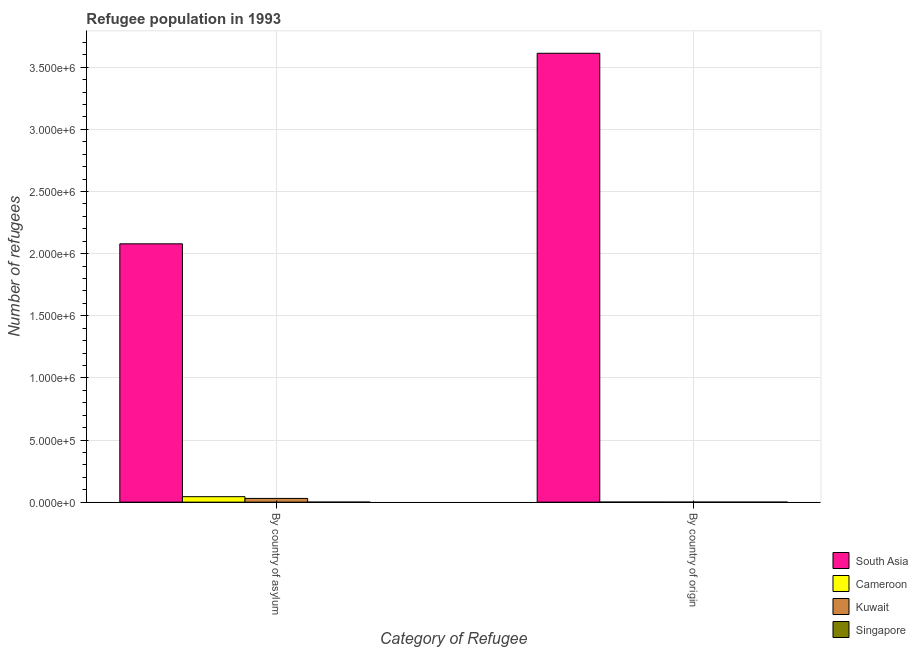How many groups of bars are there?
Offer a very short reply. 2. How many bars are there on the 1st tick from the left?
Ensure brevity in your answer.  4. How many bars are there on the 2nd tick from the right?
Make the answer very short. 4. What is the label of the 1st group of bars from the left?
Keep it short and to the point. By country of asylum. What is the number of refugees by country of asylum in Cameroon?
Provide a succinct answer. 4.40e+04. Across all countries, what is the maximum number of refugees by country of origin?
Offer a very short reply. 3.61e+06. Across all countries, what is the minimum number of refugees by country of asylum?
Ensure brevity in your answer.  11. In which country was the number of refugees by country of asylum minimum?
Your response must be concise. Singapore. What is the total number of refugees by country of asylum in the graph?
Provide a short and direct response. 2.15e+06. What is the difference between the number of refugees by country of origin in Singapore and that in Cameroon?
Provide a succinct answer. -172. What is the difference between the number of refugees by country of asylum in Cameroon and the number of refugees by country of origin in South Asia?
Provide a short and direct response. -3.57e+06. What is the average number of refugees by country of origin per country?
Keep it short and to the point. 9.03e+05. What is the difference between the number of refugees by country of asylum and number of refugees by country of origin in Singapore?
Keep it short and to the point. 10. In how many countries, is the number of refugees by country of origin greater than 700000 ?
Ensure brevity in your answer.  1. What is the ratio of the number of refugees by country of asylum in Cameroon to that in Singapore?
Your answer should be very brief. 4001.18. Is the number of refugees by country of origin in Cameroon less than that in South Asia?
Your answer should be compact. Yes. What does the 4th bar from the left in By country of origin represents?
Your response must be concise. Singapore. What does the 1st bar from the right in By country of origin represents?
Offer a terse response. Singapore. How many bars are there?
Give a very brief answer. 8. Are the values on the major ticks of Y-axis written in scientific E-notation?
Provide a short and direct response. Yes. Does the graph contain any zero values?
Provide a succinct answer. No. How are the legend labels stacked?
Offer a very short reply. Vertical. What is the title of the graph?
Your response must be concise. Refugee population in 1993. What is the label or title of the X-axis?
Provide a short and direct response. Category of Refugee. What is the label or title of the Y-axis?
Make the answer very short. Number of refugees. What is the Number of refugees of South Asia in By country of asylum?
Keep it short and to the point. 2.08e+06. What is the Number of refugees of Cameroon in By country of asylum?
Ensure brevity in your answer.  4.40e+04. What is the Number of refugees in Singapore in By country of asylum?
Provide a short and direct response. 11. What is the Number of refugees in South Asia in By country of origin?
Give a very brief answer. 3.61e+06. What is the Number of refugees of Cameroon in By country of origin?
Offer a very short reply. 173. What is the Number of refugees of Kuwait in By country of origin?
Provide a short and direct response. 89. Across all Category of Refugee, what is the maximum Number of refugees of South Asia?
Provide a succinct answer. 3.61e+06. Across all Category of Refugee, what is the maximum Number of refugees in Cameroon?
Provide a short and direct response. 4.40e+04. Across all Category of Refugee, what is the maximum Number of refugees in Kuwait?
Provide a succinct answer. 3.00e+04. Across all Category of Refugee, what is the maximum Number of refugees in Singapore?
Give a very brief answer. 11. Across all Category of Refugee, what is the minimum Number of refugees in South Asia?
Give a very brief answer. 2.08e+06. Across all Category of Refugee, what is the minimum Number of refugees of Cameroon?
Your answer should be very brief. 173. Across all Category of Refugee, what is the minimum Number of refugees of Kuwait?
Your answer should be very brief. 89. Across all Category of Refugee, what is the minimum Number of refugees of Singapore?
Ensure brevity in your answer.  1. What is the total Number of refugees of South Asia in the graph?
Give a very brief answer. 5.69e+06. What is the total Number of refugees in Cameroon in the graph?
Offer a terse response. 4.42e+04. What is the total Number of refugees in Kuwait in the graph?
Ensure brevity in your answer.  3.01e+04. What is the total Number of refugees of Singapore in the graph?
Provide a short and direct response. 12. What is the difference between the Number of refugees of South Asia in By country of asylum and that in By country of origin?
Your response must be concise. -1.53e+06. What is the difference between the Number of refugees of Cameroon in By country of asylum and that in By country of origin?
Your response must be concise. 4.38e+04. What is the difference between the Number of refugees in Kuwait in By country of asylum and that in By country of origin?
Ensure brevity in your answer.  2.99e+04. What is the difference between the Number of refugees of Singapore in By country of asylum and that in By country of origin?
Ensure brevity in your answer.  10. What is the difference between the Number of refugees in South Asia in By country of asylum and the Number of refugees in Cameroon in By country of origin?
Offer a terse response. 2.08e+06. What is the difference between the Number of refugees in South Asia in By country of asylum and the Number of refugees in Kuwait in By country of origin?
Keep it short and to the point. 2.08e+06. What is the difference between the Number of refugees in South Asia in By country of asylum and the Number of refugees in Singapore in By country of origin?
Provide a short and direct response. 2.08e+06. What is the difference between the Number of refugees of Cameroon in By country of asylum and the Number of refugees of Kuwait in By country of origin?
Provide a short and direct response. 4.39e+04. What is the difference between the Number of refugees in Cameroon in By country of asylum and the Number of refugees in Singapore in By country of origin?
Provide a short and direct response. 4.40e+04. What is the difference between the Number of refugees of Kuwait in By country of asylum and the Number of refugees of Singapore in By country of origin?
Your answer should be compact. 3.00e+04. What is the average Number of refugees in South Asia per Category of Refugee?
Offer a terse response. 2.85e+06. What is the average Number of refugees of Cameroon per Category of Refugee?
Make the answer very short. 2.21e+04. What is the average Number of refugees of Kuwait per Category of Refugee?
Provide a succinct answer. 1.50e+04. What is the difference between the Number of refugees of South Asia and Number of refugees of Cameroon in By country of asylum?
Keep it short and to the point. 2.03e+06. What is the difference between the Number of refugees in South Asia and Number of refugees in Kuwait in By country of asylum?
Offer a very short reply. 2.05e+06. What is the difference between the Number of refugees of South Asia and Number of refugees of Singapore in By country of asylum?
Offer a terse response. 2.08e+06. What is the difference between the Number of refugees in Cameroon and Number of refugees in Kuwait in By country of asylum?
Give a very brief answer. 1.40e+04. What is the difference between the Number of refugees in Cameroon and Number of refugees in Singapore in By country of asylum?
Your answer should be compact. 4.40e+04. What is the difference between the Number of refugees of Kuwait and Number of refugees of Singapore in By country of asylum?
Ensure brevity in your answer.  3.00e+04. What is the difference between the Number of refugees of South Asia and Number of refugees of Cameroon in By country of origin?
Your response must be concise. 3.61e+06. What is the difference between the Number of refugees of South Asia and Number of refugees of Kuwait in By country of origin?
Provide a short and direct response. 3.61e+06. What is the difference between the Number of refugees of South Asia and Number of refugees of Singapore in By country of origin?
Your answer should be very brief. 3.61e+06. What is the difference between the Number of refugees of Cameroon and Number of refugees of Singapore in By country of origin?
Your response must be concise. 172. What is the difference between the Number of refugees of Kuwait and Number of refugees of Singapore in By country of origin?
Make the answer very short. 88. What is the ratio of the Number of refugees in South Asia in By country of asylum to that in By country of origin?
Your response must be concise. 0.58. What is the ratio of the Number of refugees in Cameroon in By country of asylum to that in By country of origin?
Provide a short and direct response. 254.41. What is the ratio of the Number of refugees of Kuwait in By country of asylum to that in By country of origin?
Give a very brief answer. 337.08. What is the ratio of the Number of refugees of Singapore in By country of asylum to that in By country of origin?
Offer a very short reply. 11. What is the difference between the highest and the second highest Number of refugees of South Asia?
Make the answer very short. 1.53e+06. What is the difference between the highest and the second highest Number of refugees of Cameroon?
Keep it short and to the point. 4.38e+04. What is the difference between the highest and the second highest Number of refugees of Kuwait?
Keep it short and to the point. 2.99e+04. What is the difference between the highest and the second highest Number of refugees of Singapore?
Provide a succinct answer. 10. What is the difference between the highest and the lowest Number of refugees of South Asia?
Offer a terse response. 1.53e+06. What is the difference between the highest and the lowest Number of refugees in Cameroon?
Provide a succinct answer. 4.38e+04. What is the difference between the highest and the lowest Number of refugees of Kuwait?
Offer a very short reply. 2.99e+04. What is the difference between the highest and the lowest Number of refugees in Singapore?
Provide a succinct answer. 10. 